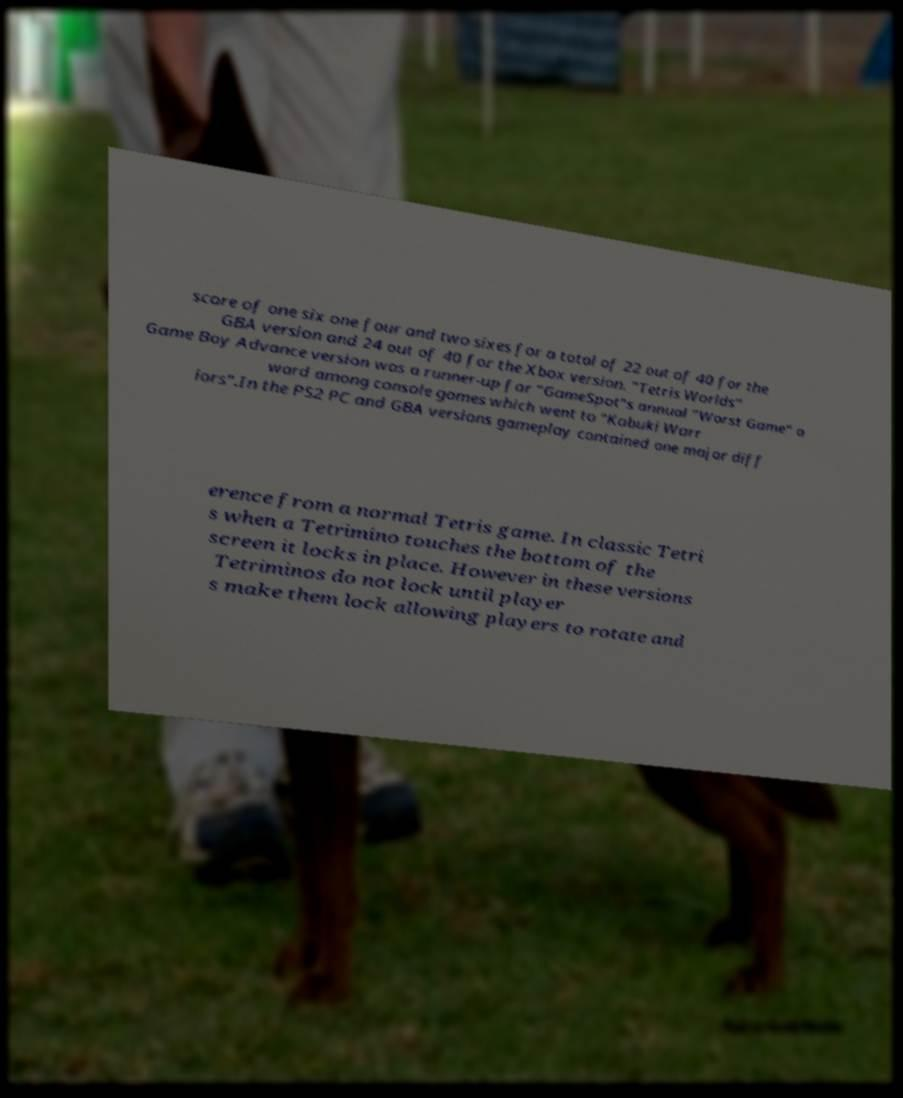I need the written content from this picture converted into text. Can you do that? score of one six one four and two sixes for a total of 22 out of 40 for the GBA version and 24 out of 40 for the Xbox version. "Tetris Worlds" Game Boy Advance version was a runner-up for "GameSpot"s annual "Worst Game" a ward among console games which went to "Kabuki Warr iors".In the PS2 PC and GBA versions gameplay contained one major diff erence from a normal Tetris game. In classic Tetri s when a Tetrimino touches the bottom of the screen it locks in place. However in these versions Tetriminos do not lock until player s make them lock allowing players to rotate and 